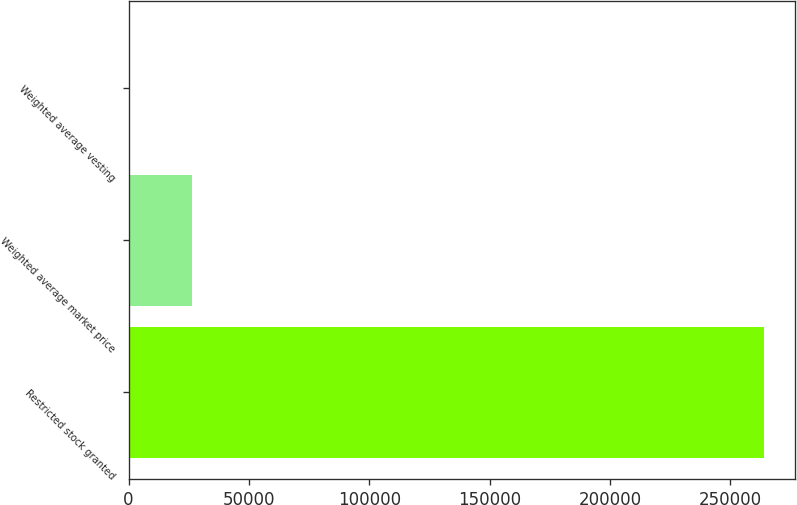<chart> <loc_0><loc_0><loc_500><loc_500><bar_chart><fcel>Restricted stock granted<fcel>Weighted average market price<fcel>Weighted average vesting<nl><fcel>263771<fcel>26379.9<fcel>3.09<nl></chart> 